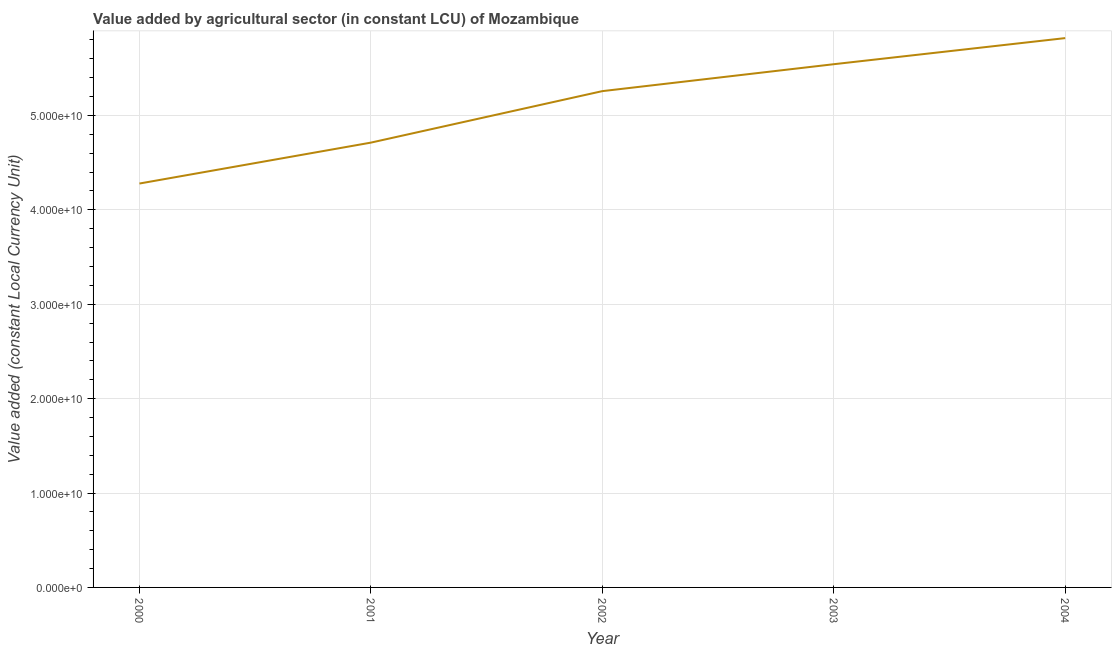What is the value added by agriculture sector in 2000?
Give a very brief answer. 4.28e+1. Across all years, what is the maximum value added by agriculture sector?
Provide a succinct answer. 5.82e+1. Across all years, what is the minimum value added by agriculture sector?
Give a very brief answer. 4.28e+1. In which year was the value added by agriculture sector maximum?
Give a very brief answer. 2004. What is the sum of the value added by agriculture sector?
Ensure brevity in your answer.  2.56e+11. What is the difference between the value added by agriculture sector in 2001 and 2002?
Offer a terse response. -5.46e+09. What is the average value added by agriculture sector per year?
Offer a terse response. 5.12e+1. What is the median value added by agriculture sector?
Your response must be concise. 5.26e+1. What is the ratio of the value added by agriculture sector in 2000 to that in 2002?
Your answer should be very brief. 0.81. What is the difference between the highest and the second highest value added by agriculture sector?
Your response must be concise. 2.77e+09. Is the sum of the value added by agriculture sector in 2002 and 2003 greater than the maximum value added by agriculture sector across all years?
Make the answer very short. Yes. What is the difference between the highest and the lowest value added by agriculture sector?
Your answer should be very brief. 1.54e+1. How many lines are there?
Offer a very short reply. 1. How many years are there in the graph?
Provide a succinct answer. 5. What is the title of the graph?
Your response must be concise. Value added by agricultural sector (in constant LCU) of Mozambique. What is the label or title of the Y-axis?
Make the answer very short. Value added (constant Local Currency Unit). What is the Value added (constant Local Currency Unit) of 2000?
Your response must be concise. 4.28e+1. What is the Value added (constant Local Currency Unit) of 2001?
Make the answer very short. 4.71e+1. What is the Value added (constant Local Currency Unit) of 2002?
Offer a terse response. 5.26e+1. What is the Value added (constant Local Currency Unit) of 2003?
Your response must be concise. 5.54e+1. What is the Value added (constant Local Currency Unit) of 2004?
Make the answer very short. 5.82e+1. What is the difference between the Value added (constant Local Currency Unit) in 2000 and 2001?
Make the answer very short. -4.33e+09. What is the difference between the Value added (constant Local Currency Unit) in 2000 and 2002?
Offer a very short reply. -9.79e+09. What is the difference between the Value added (constant Local Currency Unit) in 2000 and 2003?
Provide a succinct answer. -1.26e+1. What is the difference between the Value added (constant Local Currency Unit) in 2000 and 2004?
Make the answer very short. -1.54e+1. What is the difference between the Value added (constant Local Currency Unit) in 2001 and 2002?
Your answer should be very brief. -5.46e+09. What is the difference between the Value added (constant Local Currency Unit) in 2001 and 2003?
Provide a short and direct response. -8.31e+09. What is the difference between the Value added (constant Local Currency Unit) in 2001 and 2004?
Your answer should be very brief. -1.11e+1. What is the difference between the Value added (constant Local Currency Unit) in 2002 and 2003?
Provide a short and direct response. -2.85e+09. What is the difference between the Value added (constant Local Currency Unit) in 2002 and 2004?
Ensure brevity in your answer.  -5.62e+09. What is the difference between the Value added (constant Local Currency Unit) in 2003 and 2004?
Provide a succinct answer. -2.77e+09. What is the ratio of the Value added (constant Local Currency Unit) in 2000 to that in 2001?
Ensure brevity in your answer.  0.91. What is the ratio of the Value added (constant Local Currency Unit) in 2000 to that in 2002?
Ensure brevity in your answer.  0.81. What is the ratio of the Value added (constant Local Currency Unit) in 2000 to that in 2003?
Keep it short and to the point. 0.77. What is the ratio of the Value added (constant Local Currency Unit) in 2000 to that in 2004?
Your answer should be compact. 0.73. What is the ratio of the Value added (constant Local Currency Unit) in 2001 to that in 2002?
Your answer should be compact. 0.9. What is the ratio of the Value added (constant Local Currency Unit) in 2001 to that in 2004?
Keep it short and to the point. 0.81. What is the ratio of the Value added (constant Local Currency Unit) in 2002 to that in 2003?
Provide a succinct answer. 0.95. What is the ratio of the Value added (constant Local Currency Unit) in 2002 to that in 2004?
Offer a terse response. 0.9. 